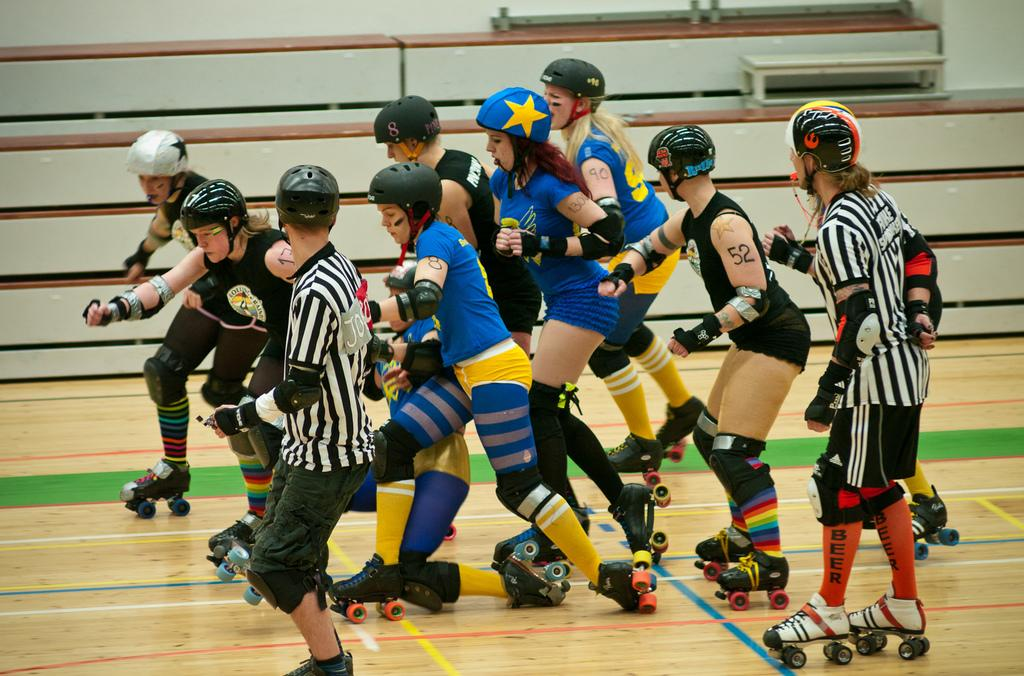What is happening in the image involving a group of people? There is a group of people in the image, and they are skating on the ground. What are the people wearing on their heads? The people are wearing helmets. What can be seen in the background of the image? There are objects visible in the background of the image. What type of ink is being used by the people to teach in the image? There is no indication in the image that the people are teaching or using ink. 